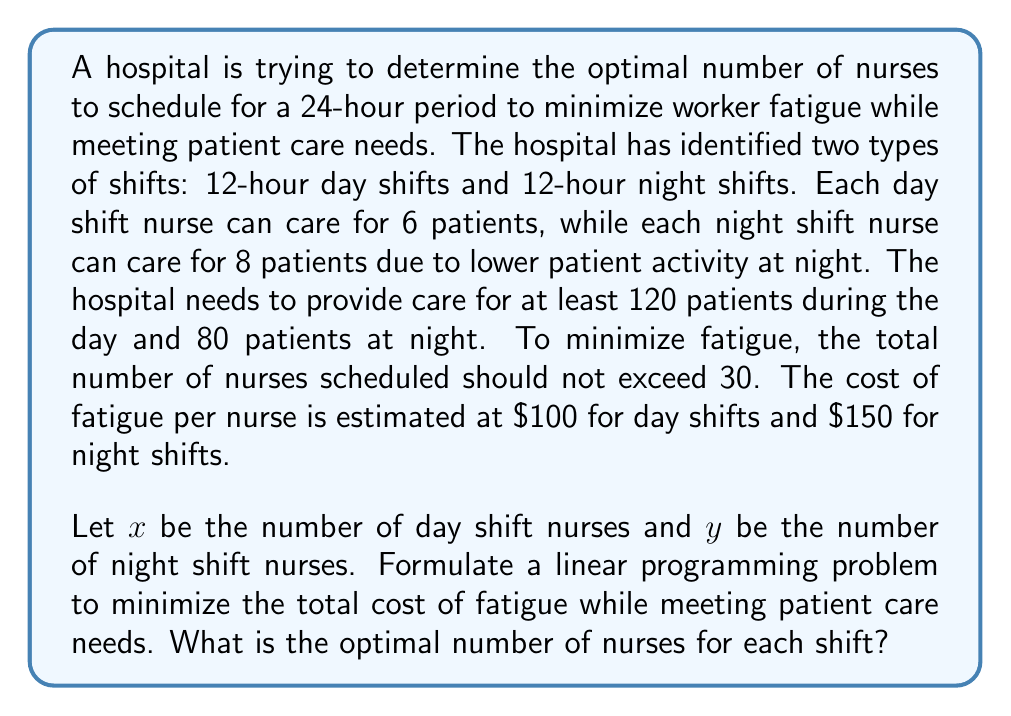Provide a solution to this math problem. To solve this problem, we'll follow these steps:

1. Define the objective function:
   Minimize $Z = 100x + 150y$ (total cost of fatigue)

2. Identify the constraints:
   a. Day shift patient care: $6x \geq 120$
   b. Night shift patient care: $8y \geq 80$
   c. Total nurses: $x + y \leq 30$
   d. Non-negativity: $x \geq 0, y \geq 0$

3. Simplify the constraints:
   a. $x \geq 20$
   b. $y \geq 10$
   c. $x + y \leq 30$

4. Plot the feasible region:
   [asy]
   import geometry;
   
   size(200);
   
   real xmax = 35;
   real ymax = 35;
   
   draw((0,0)--(xmax,0)--(xmax,ymax)--(0,ymax)--cycle);
   draw((20,0)--(20,ymax),dashed);
   draw((0,10)--(xmax,10),dashed);
   draw((0,30)--(30,0),red);
   
   label("$x \geq 20$", (18,ymax/2), W);
   label("$y \geq 10$", (xmax/2,8), S);
   label("$x + y = 30$", (15,15), NW);
   
   dot((20,10));
   dot((20,15));
   dot((25,10));
   
   label("A(20,10)", (20,10), SE);
   label("B(20,15)", (20,15), E);
   label("C(25,10)", (25,10), S);
   
   xaxis("$x$",0,xmax,Arrow);
   yaxis("$y$",0,ymax,Arrow);
   [/asy]

5. Identify the corner points of the feasible region:
   A(20, 10), B(20, 15), C(25, 10)

6. Evaluate the objective function at each corner point:
   A: $Z = 100(20) + 150(10) = 3500$
   B: $Z = 100(20) + 150(15) = 4250$
   C: $Z = 100(25) + 150(10) = 4000$

7. The minimum value occurs at point A(20, 10).

Therefore, the optimal solution is to schedule 20 nurses for the day shift and 10 nurses for the night shift.
Answer: 20 day shift nurses, 10 night shift nurses 